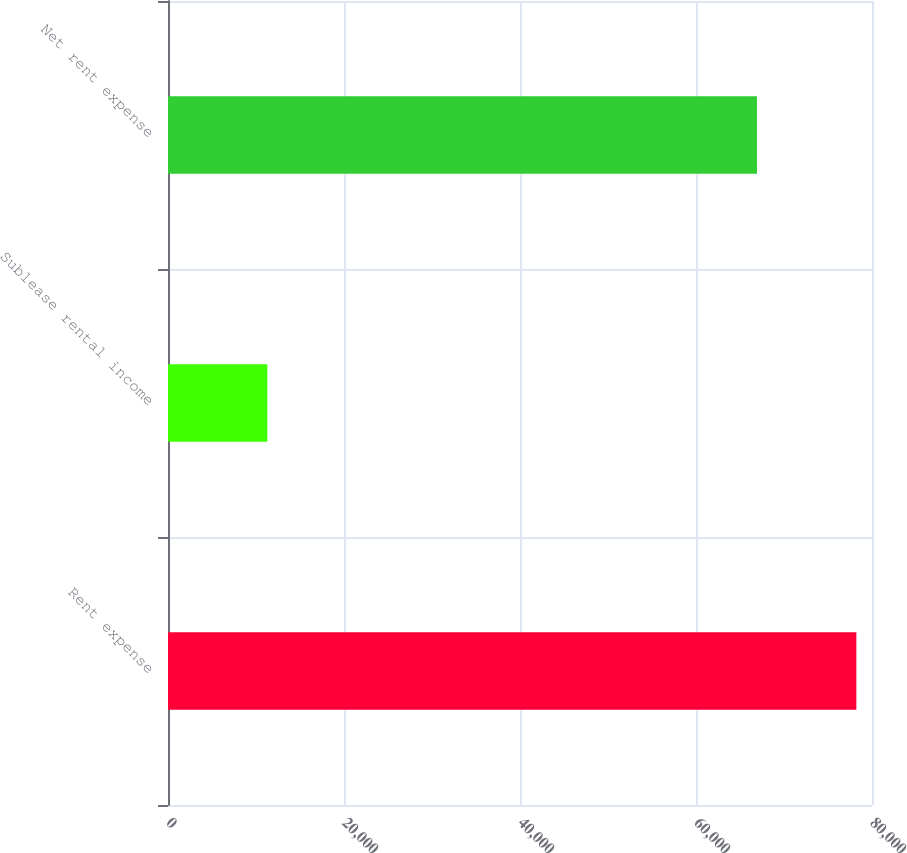<chart> <loc_0><loc_0><loc_500><loc_500><bar_chart><fcel>Rent expense<fcel>Sublease rental income<fcel>Net rent expense<nl><fcel>78222<fcel>11291<fcel>66931<nl></chart> 